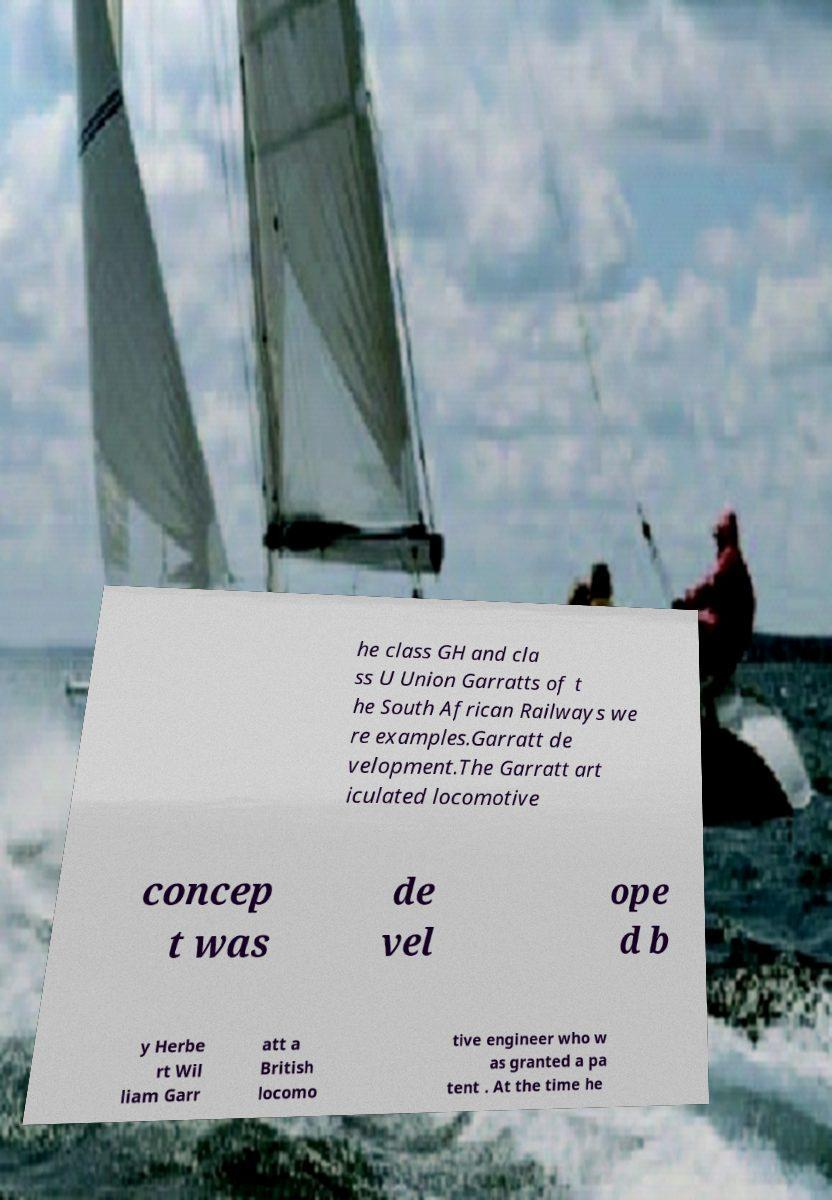Could you extract and type out the text from this image? he class GH and cla ss U Union Garratts of t he South African Railways we re examples.Garratt de velopment.The Garratt art iculated locomotive concep t was de vel ope d b y Herbe rt Wil liam Garr att a British locomo tive engineer who w as granted a pa tent . At the time he 